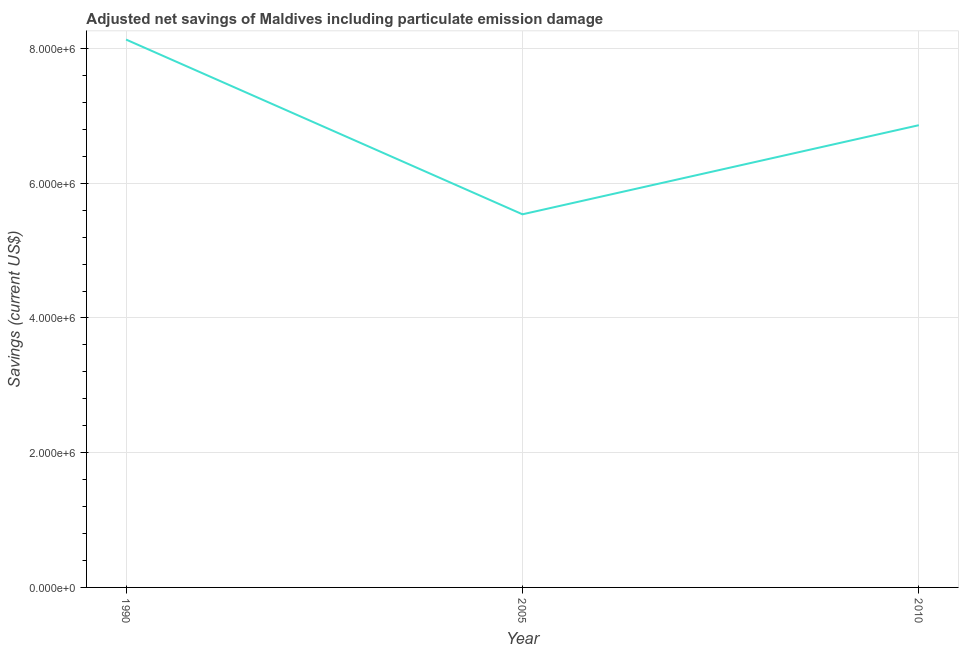What is the adjusted net savings in 2010?
Give a very brief answer. 6.86e+06. Across all years, what is the maximum adjusted net savings?
Give a very brief answer. 8.13e+06. Across all years, what is the minimum adjusted net savings?
Keep it short and to the point. 5.54e+06. What is the sum of the adjusted net savings?
Offer a very short reply. 2.05e+07. What is the difference between the adjusted net savings in 1990 and 2005?
Make the answer very short. 2.59e+06. What is the average adjusted net savings per year?
Provide a succinct answer. 6.85e+06. What is the median adjusted net savings?
Make the answer very short. 6.86e+06. In how many years, is the adjusted net savings greater than 400000 US$?
Provide a succinct answer. 3. Do a majority of the years between 2010 and 2005 (inclusive) have adjusted net savings greater than 7600000 US$?
Provide a succinct answer. No. What is the ratio of the adjusted net savings in 1990 to that in 2005?
Provide a short and direct response. 1.47. Is the adjusted net savings in 1990 less than that in 2010?
Provide a short and direct response. No. Is the difference between the adjusted net savings in 2005 and 2010 greater than the difference between any two years?
Provide a succinct answer. No. What is the difference between the highest and the second highest adjusted net savings?
Ensure brevity in your answer.  1.27e+06. What is the difference between the highest and the lowest adjusted net savings?
Keep it short and to the point. 2.59e+06. How many lines are there?
Your response must be concise. 1. How many years are there in the graph?
Your response must be concise. 3. What is the difference between two consecutive major ticks on the Y-axis?
Offer a very short reply. 2.00e+06. Are the values on the major ticks of Y-axis written in scientific E-notation?
Keep it short and to the point. Yes. Does the graph contain any zero values?
Provide a short and direct response. No. Does the graph contain grids?
Your response must be concise. Yes. What is the title of the graph?
Provide a succinct answer. Adjusted net savings of Maldives including particulate emission damage. What is the label or title of the Y-axis?
Your response must be concise. Savings (current US$). What is the Savings (current US$) of 1990?
Give a very brief answer. 8.13e+06. What is the Savings (current US$) of 2005?
Offer a very short reply. 5.54e+06. What is the Savings (current US$) of 2010?
Offer a terse response. 6.86e+06. What is the difference between the Savings (current US$) in 1990 and 2005?
Your answer should be compact. 2.59e+06. What is the difference between the Savings (current US$) in 1990 and 2010?
Ensure brevity in your answer.  1.27e+06. What is the difference between the Savings (current US$) in 2005 and 2010?
Provide a succinct answer. -1.32e+06. What is the ratio of the Savings (current US$) in 1990 to that in 2005?
Provide a succinct answer. 1.47. What is the ratio of the Savings (current US$) in 1990 to that in 2010?
Your response must be concise. 1.19. What is the ratio of the Savings (current US$) in 2005 to that in 2010?
Make the answer very short. 0.81. 